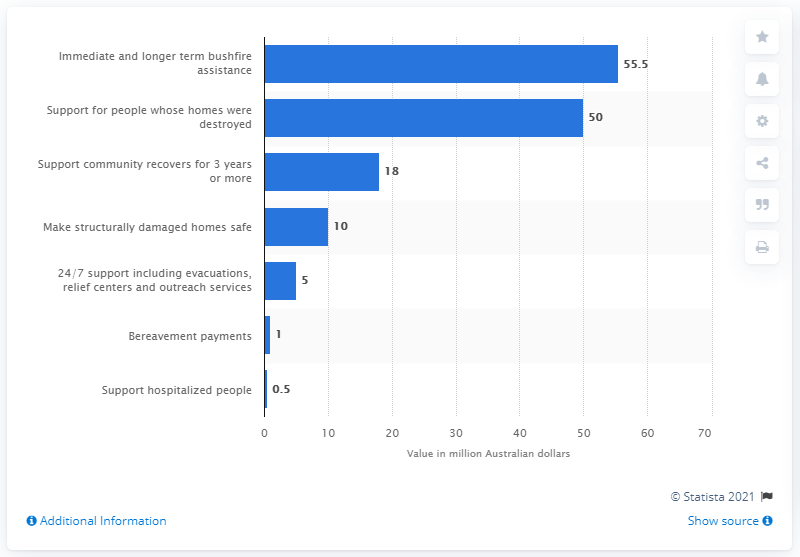Outline some significant characteristics in this image. The Red Cross allocated $50 million to people whose homes had been destroyed. The Australian Red Cross allocated $55.5 million for bushfire assistance. 